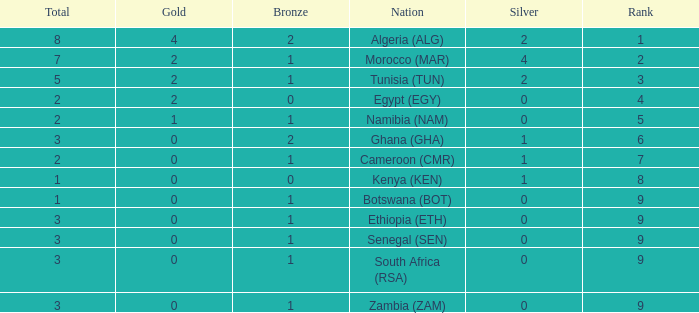What is the total number of Silver with a Total that is smaller than 1? 0.0. 